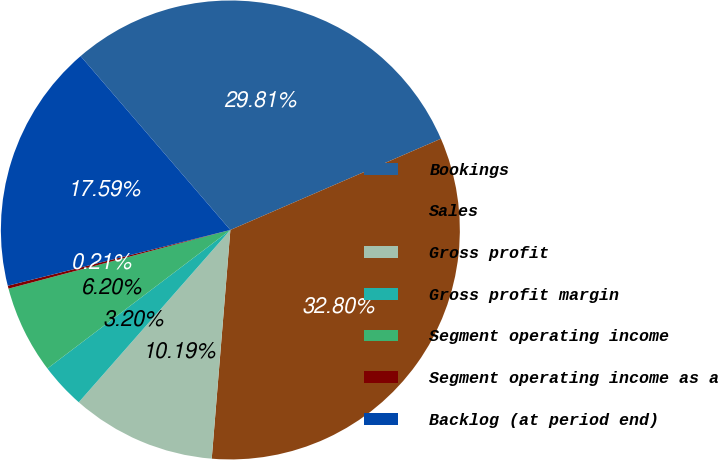<chart> <loc_0><loc_0><loc_500><loc_500><pie_chart><fcel>Bookings<fcel>Sales<fcel>Gross profit<fcel>Gross profit margin<fcel>Segment operating income<fcel>Segment operating income as a<fcel>Backlog (at period end)<nl><fcel>29.81%<fcel>32.8%<fcel>10.19%<fcel>3.2%<fcel>6.2%<fcel>0.21%<fcel>17.59%<nl></chart> 